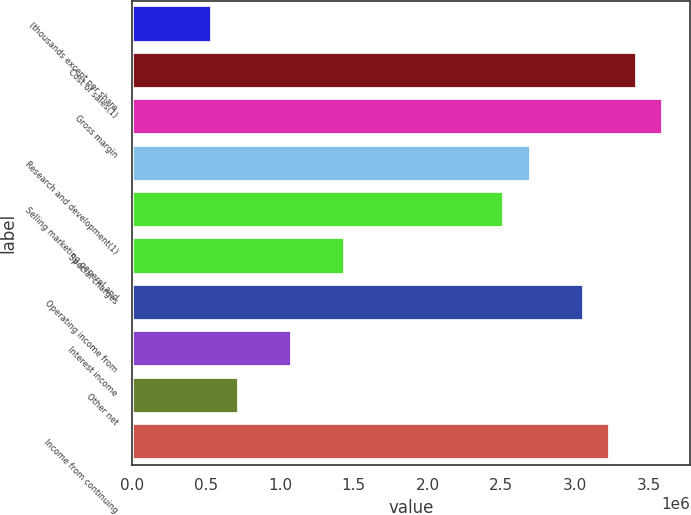Convert chart. <chart><loc_0><loc_0><loc_500><loc_500><bar_chart><fcel>(thousands except per share<fcel>Cost of sales(1)<fcel>Gross margin<fcel>Research and development(1)<fcel>Selling marketing general and<fcel>Special charges<fcel>Operating income from<fcel>Interest income<fcel>Other net<fcel>Income from continuing<nl><fcel>539827<fcel>3.4189e+06<fcel>3.59884e+06<fcel>2.69913e+06<fcel>2.51919e+06<fcel>1.43954e+06<fcel>3.05902e+06<fcel>1.07965e+06<fcel>719769<fcel>3.23896e+06<nl></chart> 